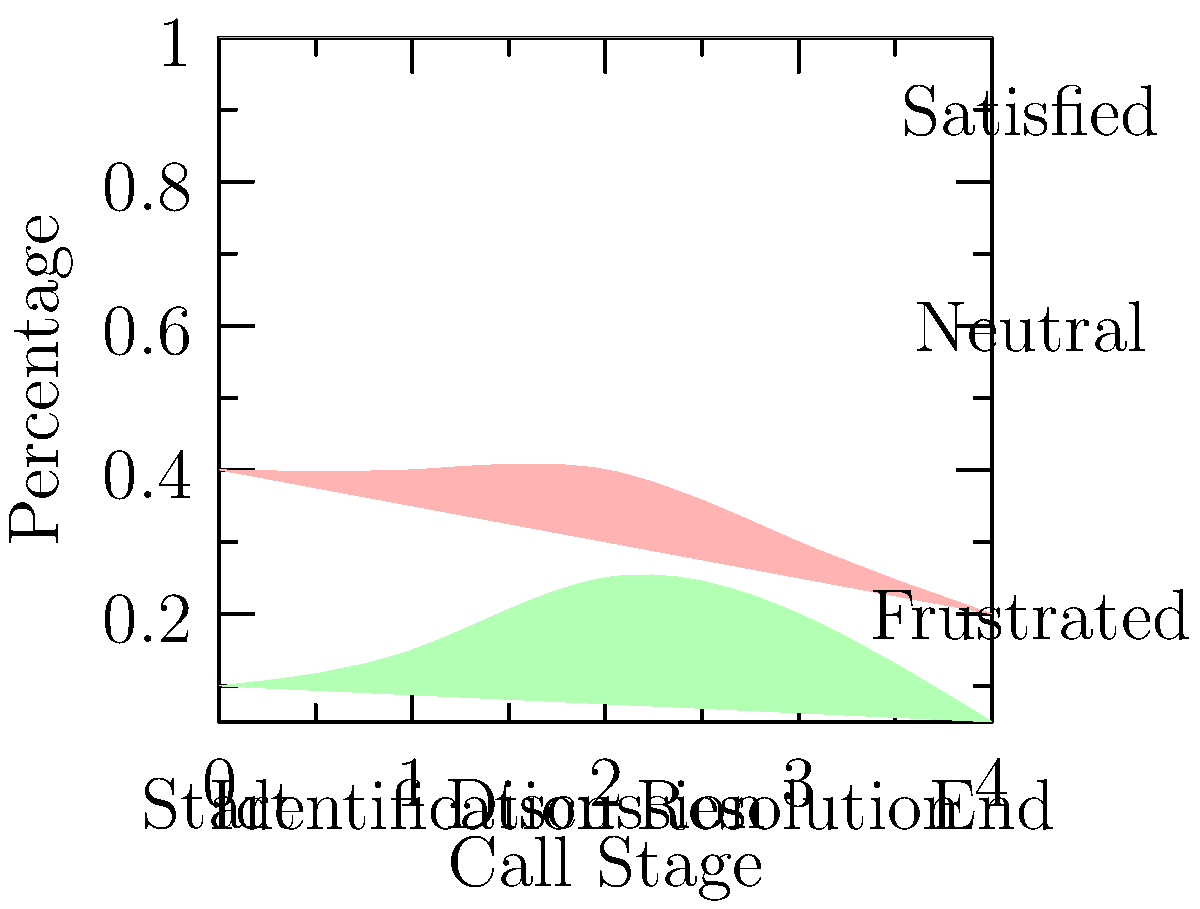Based on the stacked area chart showing customer emotions during different stages of a call, at which stage does the proportion of frustrated customers reach its peak? To determine when the proportion of frustrated customers reaches its peak, we need to analyze the bottom layer of the stacked area chart, which represents frustrated customers. Let's examine each stage:

1. Start: The frustrated customer area is relatively small.
2. Identification: The frustrated customer area increases slightly.
3. Discussion: The frustrated customer area reaches its widest point here.
4. Resolution: The frustrated customer area starts to decrease.
5. End: The frustrated customer area is at its smallest.

The widest point of the bottom layer (green area) represents the highest proportion of frustrated customers. This occurs during the "Discussion" stage, which is the third stage of the call.

It's important to note that during this stage, customer service representatives should be especially attentive to de-escalation techniques, as this is when customers are most likely to be frustrated.
Answer: Discussion stage 